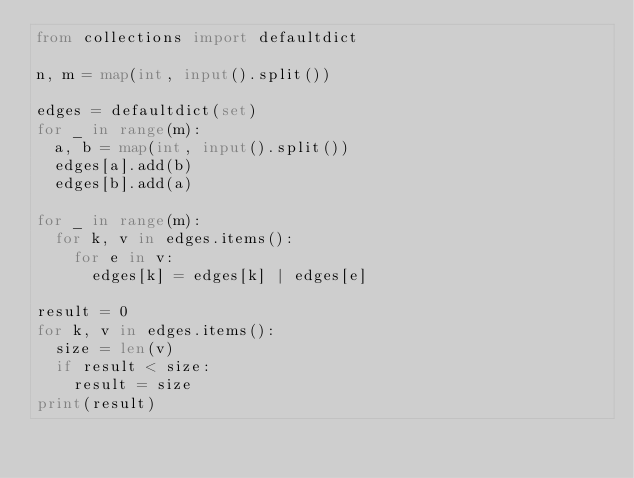<code> <loc_0><loc_0><loc_500><loc_500><_Python_>from collections import defaultdict

n, m = map(int, input().split())

edges = defaultdict(set)
for _ in range(m):
  a, b = map(int, input().split())
  edges[a].add(b)
  edges[b].add(a)
  
for _ in range(m):
  for k, v in edges.items():
    for e in v:
      edges[k] = edges[k] | edges[e]

result = 0
for k, v in edges.items():
  size = len(v)
  if result < size:
    result = size
print(result)</code> 